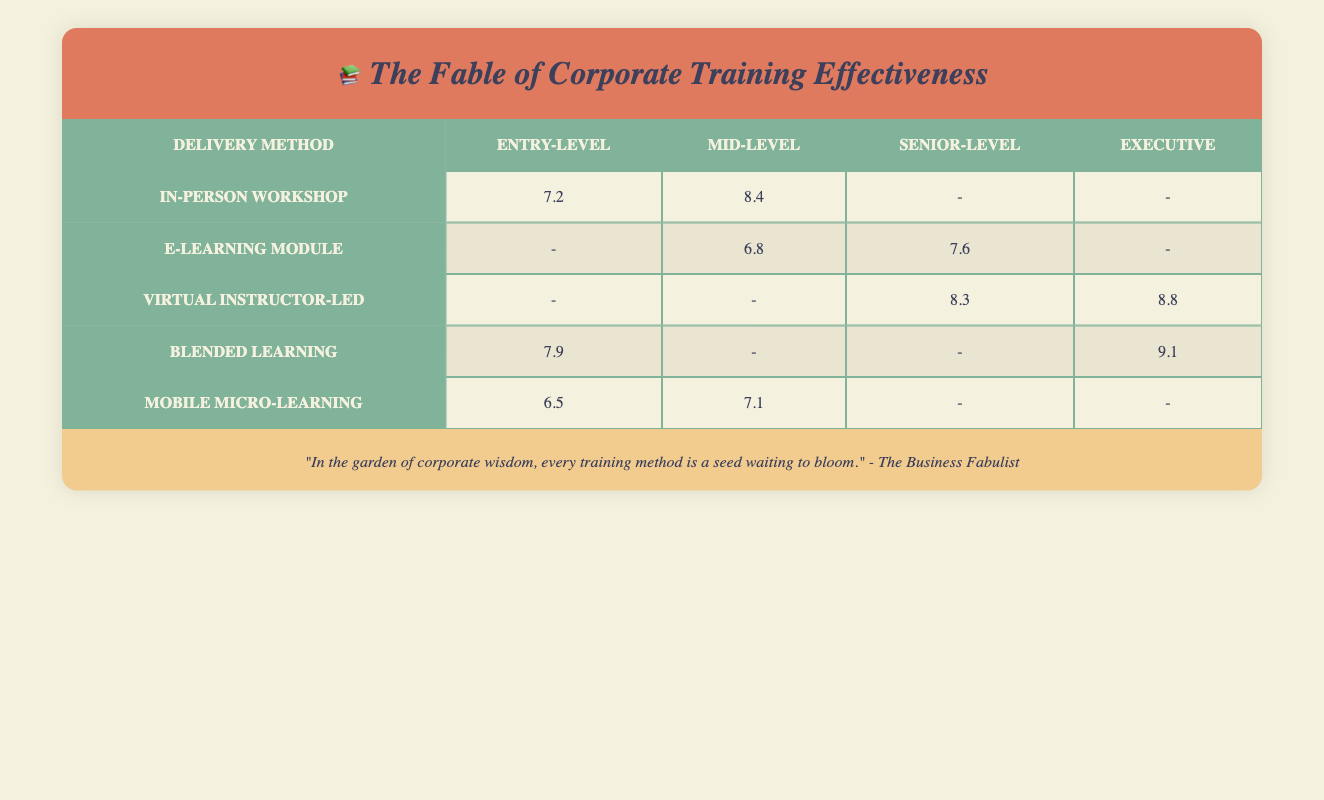What is the effectiveness score of the In-person workshop for Entry-level participants? Looking at the table, under the "In-person workshop" row and the "Entry-level" column, the effectiveness score is 7.2.
Answer: 7.2 Which delivery method has the highest effectiveness score for Executive-level participants? From the "Executive" column, the highest effectiveness score is found in the "Blended learning" row with a score of 9.1.
Answer: 9.1 Is the mobile micro-learning method effective for Senior-level participants? Looking at the table, there is no effectiveness score listed for the "Mobile micro-learning" method under the "Senior-level" column, indicating that there is no data available.
Answer: No What is the average effectiveness score for Entry-level participants across all delivery methods? The effectiveness scores for Entry-level participants are 7.2 (In-person workshop), 6.5 (Mobile micro-learning), and 7.9 (Blended learning). Adding these scores gives 7.2 + 6.5 + 7.9 = 21.6. Dividing by the number of scores (3) results in an average of 21.6 / 3 = 7.2.
Answer: 7.2 Which delivery method shows a significant difference in effectiveness scores between Mid-level and Senior-level participants? From the table, "In-person workshop" has scores of 8.4 for Mid-level and no data for Senior-level, but "E-learning module" has scores of 6.8 for Mid-level and 7.6 for Senior-level. The highest difference is the "Virtual instructor-led" with 8.3 (Senior-level) versus no data for Mid-level.
Answer: "Virtual instructor-led" shows a significant difference of 8.3 (Senior-level) What is the satisfaction rate of the blended learning method for Executive-level participants? In the "Blended learning" row and the "Executive" column, the participant satisfaction is listed as 9.1.
Answer: 9.1 Are there any delivery methods that had a lower effectiveness score for Entry-level participants compared to Mid-level participants? The scores show "Mobile micro-learning" at 6.5 for Entry-level and "E-learning module" at 6.8 for Mid-level. Thus, Mobile micro-learning is lower but not the only comparison; In-person workshop has 7.2 for Entry-level and 8.4 for Mid-level which is also a lower comparison.
Answer: Yes What is the combined effectiveness score for Mid-level and Senior-level participants in the Virtual instructor-led training method? For Mid-level, the effectiveness score is not listed, while for Senior-level, it is 8.3. Therefore, only 8.3 is counted since there’s no data for Mid-level under this method leading to a combined score of just 8.3.
Answer: 8.3 